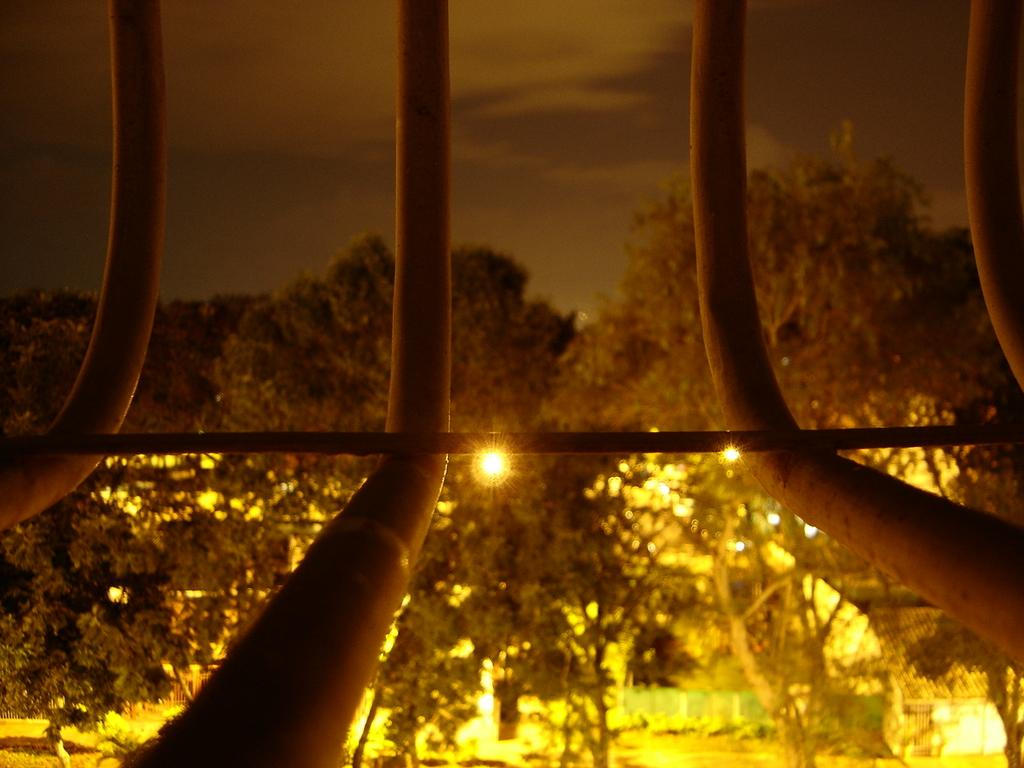What objects can be seen in the image? There are rods in the image. What can be seen in the background of the image? There are trees, lights, buildings, and the sky visible in the background of the image. How many legs are visible in the image? There are no legs visible in the image; it features rods and a background with trees, lights, buildings, and the sky. 